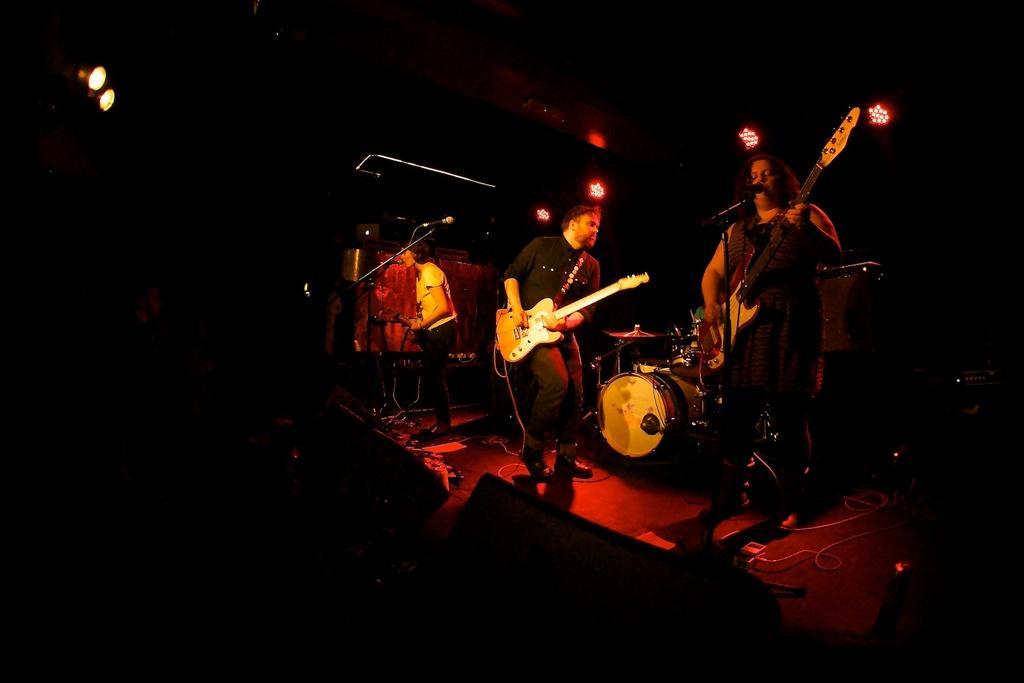How would you summarize this image in a sentence or two? In this image there are three people standing on the stage and playing guitar and in the middle of the image there are drums and at the bottom there are wires and speakers, at the top there are lights. 